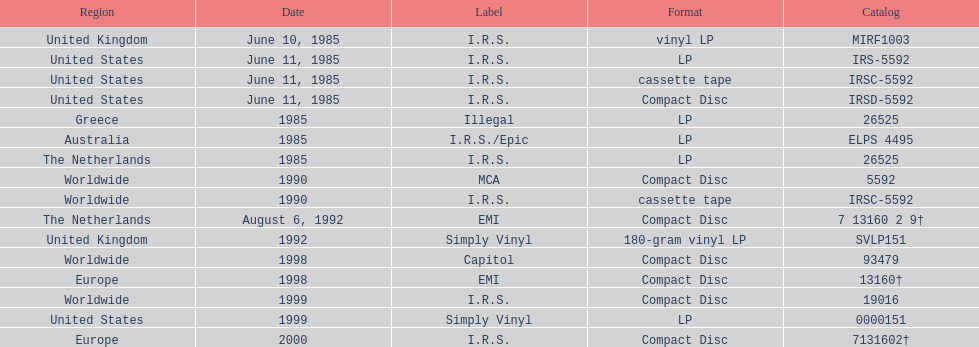Which region was the last to release? Europe. 